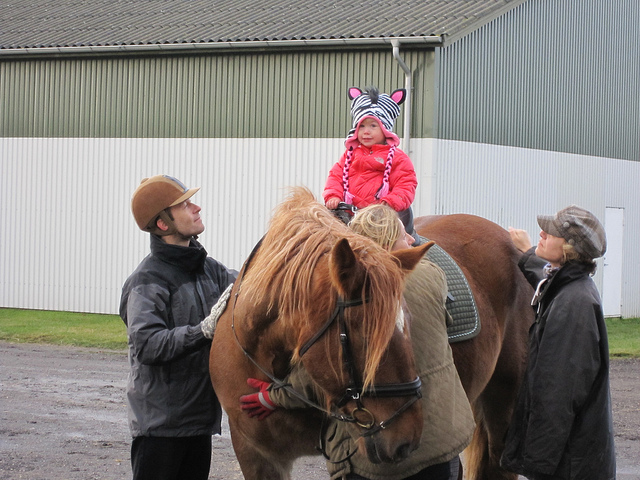<image>What color is the child's skirt? I am not sure. The child's skirt can be pink, blue, gray, black, or red. What color is the child's skirt? It is not sure what color is the child's skirt. It can be seen pink, blue, gray, black or red. 